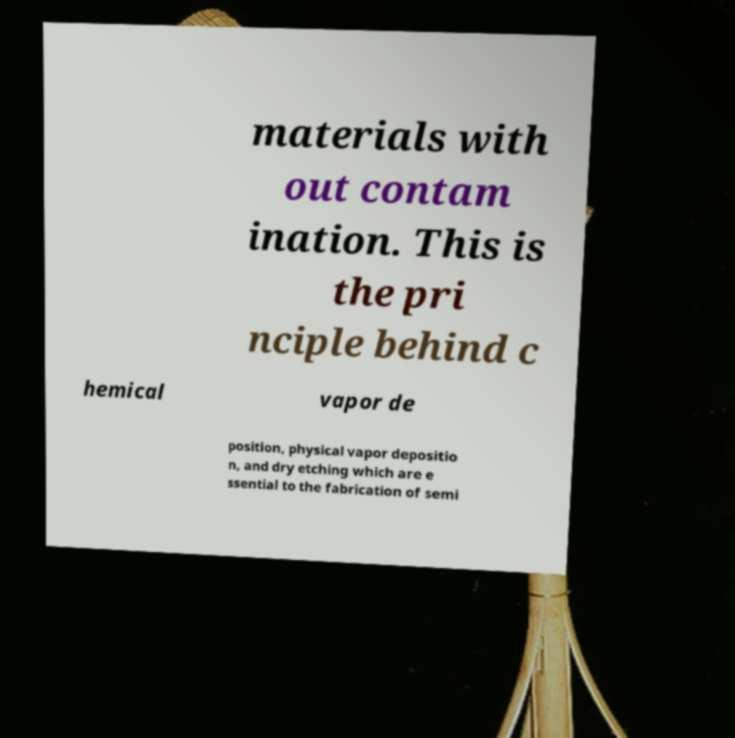Please read and relay the text visible in this image. What does it say? materials with out contam ination. This is the pri nciple behind c hemical vapor de position, physical vapor depositio n, and dry etching which are e ssential to the fabrication of semi 